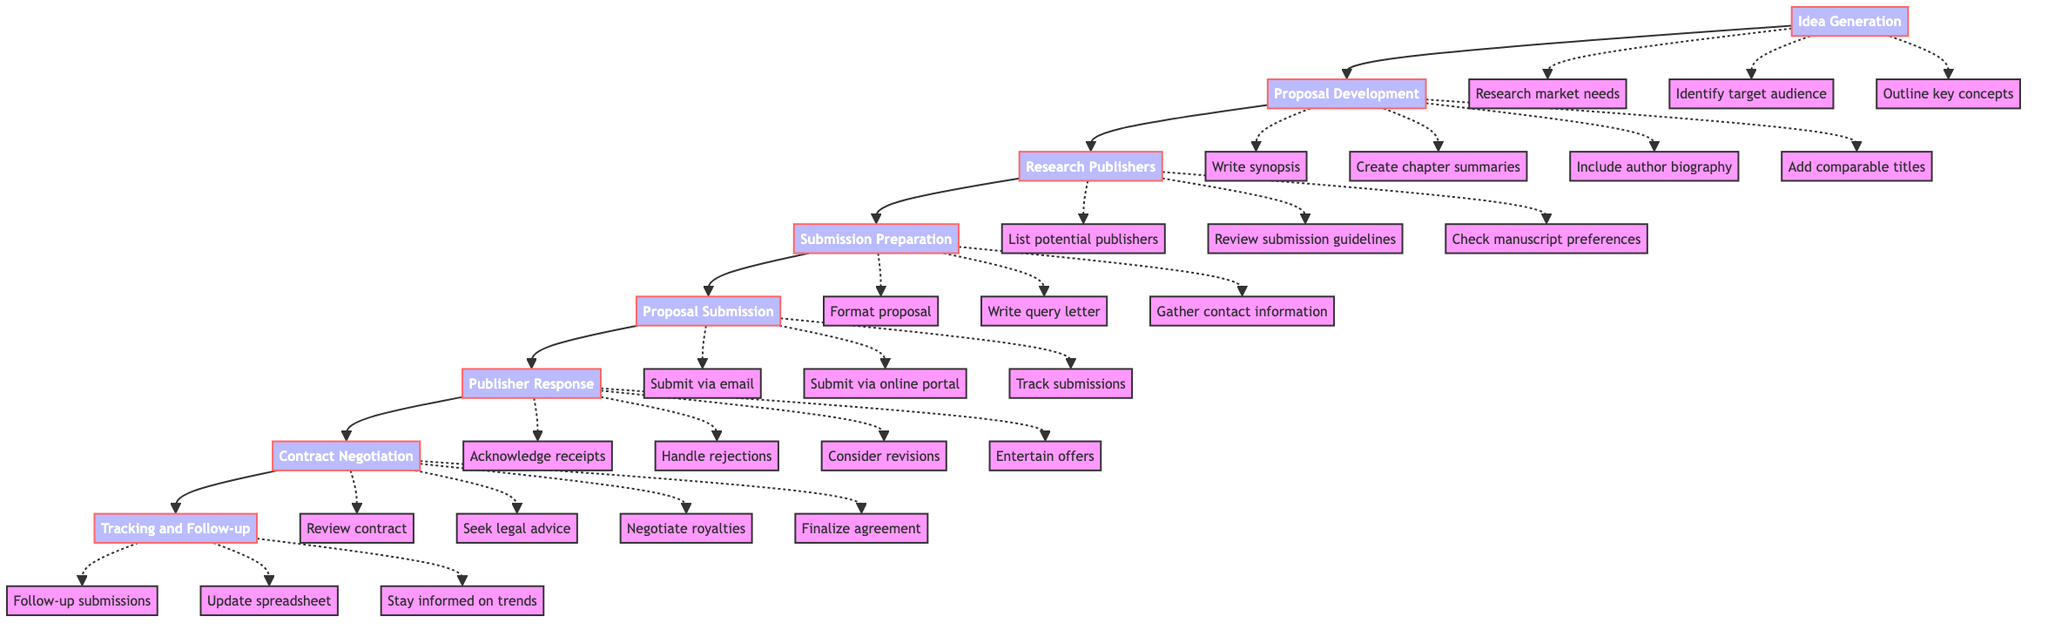What is the first step in the process? The diagram starts with the first node labeled "Idea Generation," indicating that this is the initial step in the book proposal submission process.
Answer: Idea Generation How many main steps are in the diagram? There are a total of 8 main steps listed in the flow chart, from "Idea Generation" to "Tracking and Follow-up."
Answer: 8 What follows after the "Proposal Development" step? The flow chart shows that "Proposal Development" is followed directly by "Research Publishers," as indicated by the arrow connecting these two steps.
Answer: Research Publishers What action is included in the "Proposal Submission"? The "Proposal Submission" step includes several actions, one of which is "Submit via email," as noted within the actions beneath this step.
Answer: Submit via email What is the last step in the process? The final step of the process, according to the flow chart, is labeled "Tracking and Follow-up," indicating the conclusion of the submission process.
Answer: Tracking and Follow-up What actions are associated with "Publisher Response"? The "Publisher Response" step includes several actions, such as "Acknowledge receipt confirmations" and "Handle rejections." These actions are listed as part of the procedures for responding to publishers.
Answer: Acknowledge receipt confirmations, Handle rejections How does "Research Publishers" relate to "Submission Preparation"? "Research Publishers" is a preceding step followed by "Submission Preparation," shown by the arrow connecting "Research Publishers" to "Submission Preparation," indicating the flow of actions leading towards submission.
Answer: It is a preceding step What is a crucial action during "Contract Negotiation"? One of the critical actions during "Contract Negotiation" is "Negotiate royalty rates," which underscores the importance of discussing financial terms when finalizing a contract with a publisher.
Answer: Negotiate royalty rates What action is recommended for maintaining communication after submission? The flow chart highlights "Follow-up on pending submissions" as a recommended action for maintaining communication, emphasizing the importance of staying in touch with publishers.
Answer: Follow-up on pending submissions 